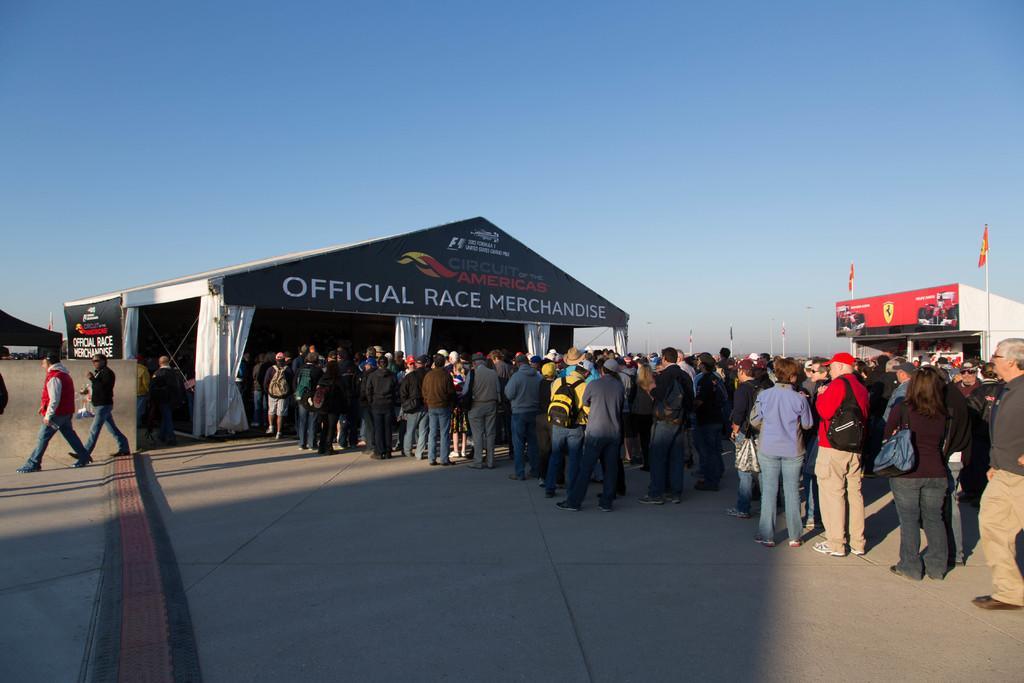In one or two sentences, can you explain what this image depicts? In this picture we can see some tents, so many people are standings in lines to enter into the tents, side we can see few people are walking. 